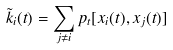Convert formula to latex. <formula><loc_0><loc_0><loc_500><loc_500>\tilde { k } _ { i } ( t ) = \sum _ { j \ne i } p _ { t } [ x _ { i } ( t ) , x _ { j } ( t ) ]</formula> 